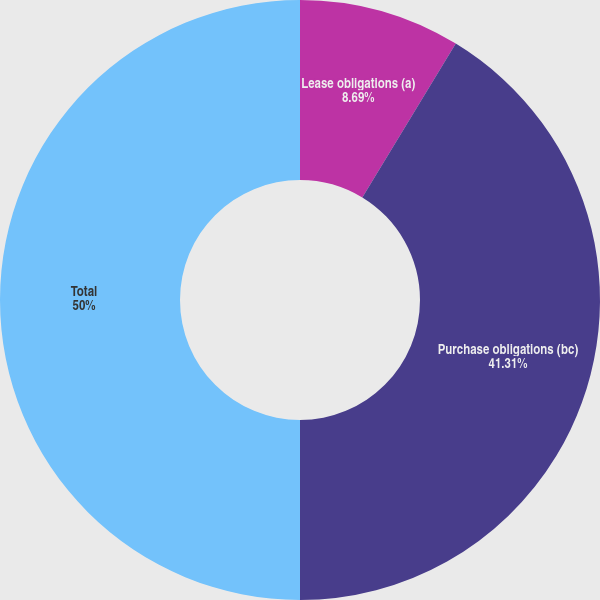<chart> <loc_0><loc_0><loc_500><loc_500><pie_chart><fcel>Lease obligations (a)<fcel>Purchase obligations (bc)<fcel>Total<nl><fcel>8.69%<fcel>41.31%<fcel>50.0%<nl></chart> 